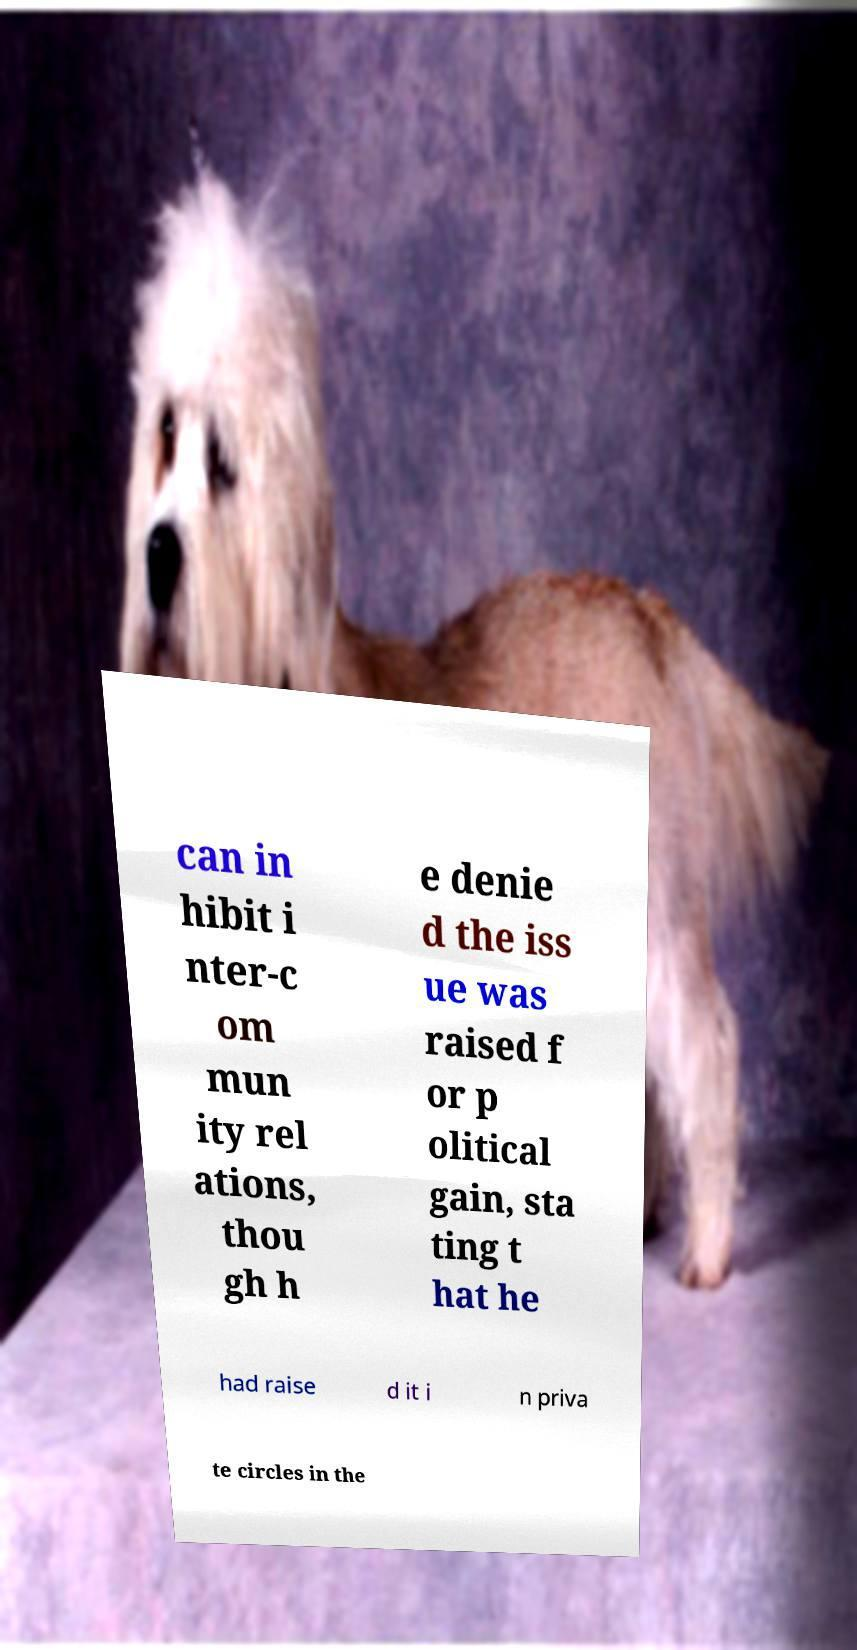For documentation purposes, I need the text within this image transcribed. Could you provide that? can in hibit i nter-c om mun ity rel ations, thou gh h e denie d the iss ue was raised f or p olitical gain, sta ting t hat he had raise d it i n priva te circles in the 